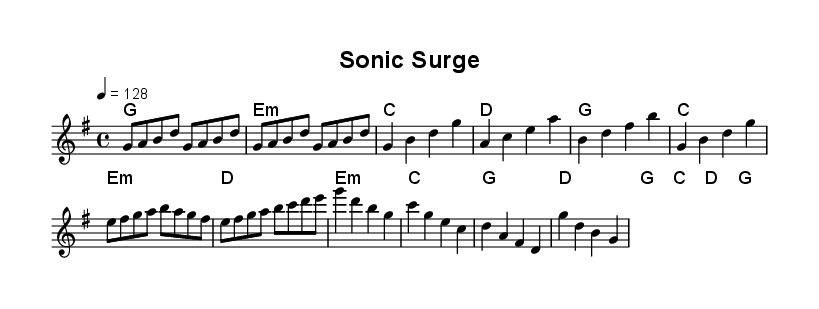What is the key signature of this music? The key signature shows one sharp (F#), indicating it is in G major.
Answer: G major What is the time signature of this music? The time signature appears at the beginning and is indicated as 4/4, meaning there are four beats in each measure.
Answer: 4/4 What is the tempo marking for this piece? The tempo marking at the beginning shows "4 = 128", meaning there are 128 quarter note beats per minute.
Answer: 128 Which chord is used in the pre-chorus? The pre-chorus uses E minor, which is indicated by the E:m chord in the harmony section.
Answer: E minor How many measures are there in the chorus? The chorus consists of four measures, as indicated by the four sets of chord changes.
Answer: 4 What is the first note of the melody? The first note of the melody is "G", which is the starting pitch of the melody section.
Answer: G What gives this track a retro feel? The inclusion of chiptune-inspired melodies and 8-bit sound effects creates the retro feel typical of video game music.
Answer: Chiptune 